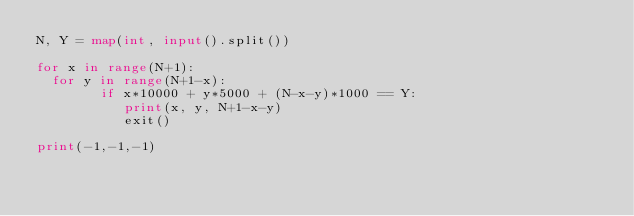<code> <loc_0><loc_0><loc_500><loc_500><_Python_>N, Y = map(int, input().split())
 
for x in range(N+1):
  for y in range(N+1-x):
        if x*10000 + y*5000 + (N-x-y)*1000 == Y:
           print(x, y, N+1-x-y)
           exit()
 
print(-1,-1,-1)</code> 